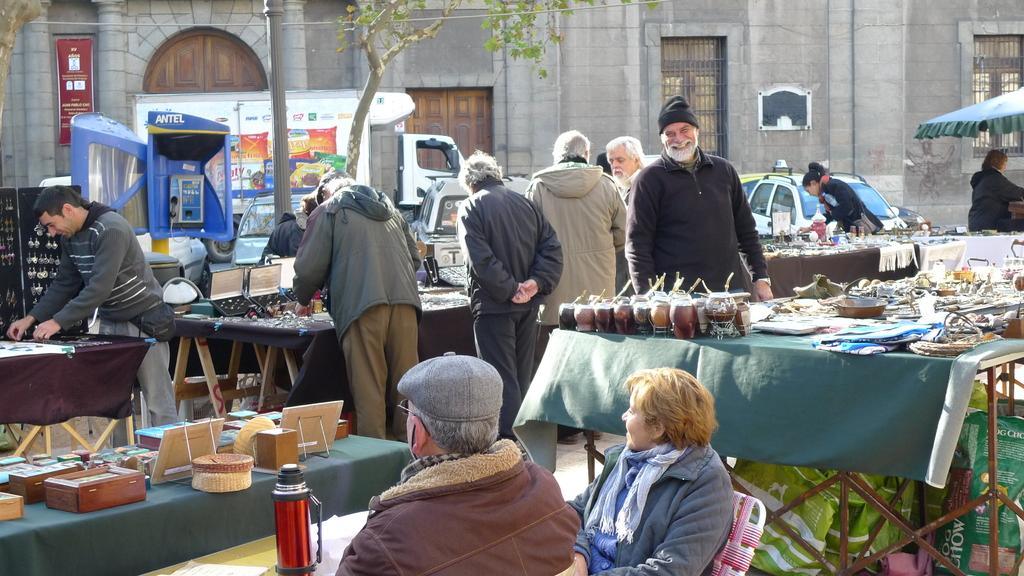How would you summarize this image in a sentence or two? In the middle of the image few people standing. Top right side of the image there is a building and window. Right side of the image there is a tent, Under the tent there is a person. Bottom right side of the image there is a table, On the table there are some few products. Bottom left side of the image there is a table, On the table there are some products. In the middle of the image there is a pole, Beside the pole there is a tree. Behind the tree there is a vehicle. 